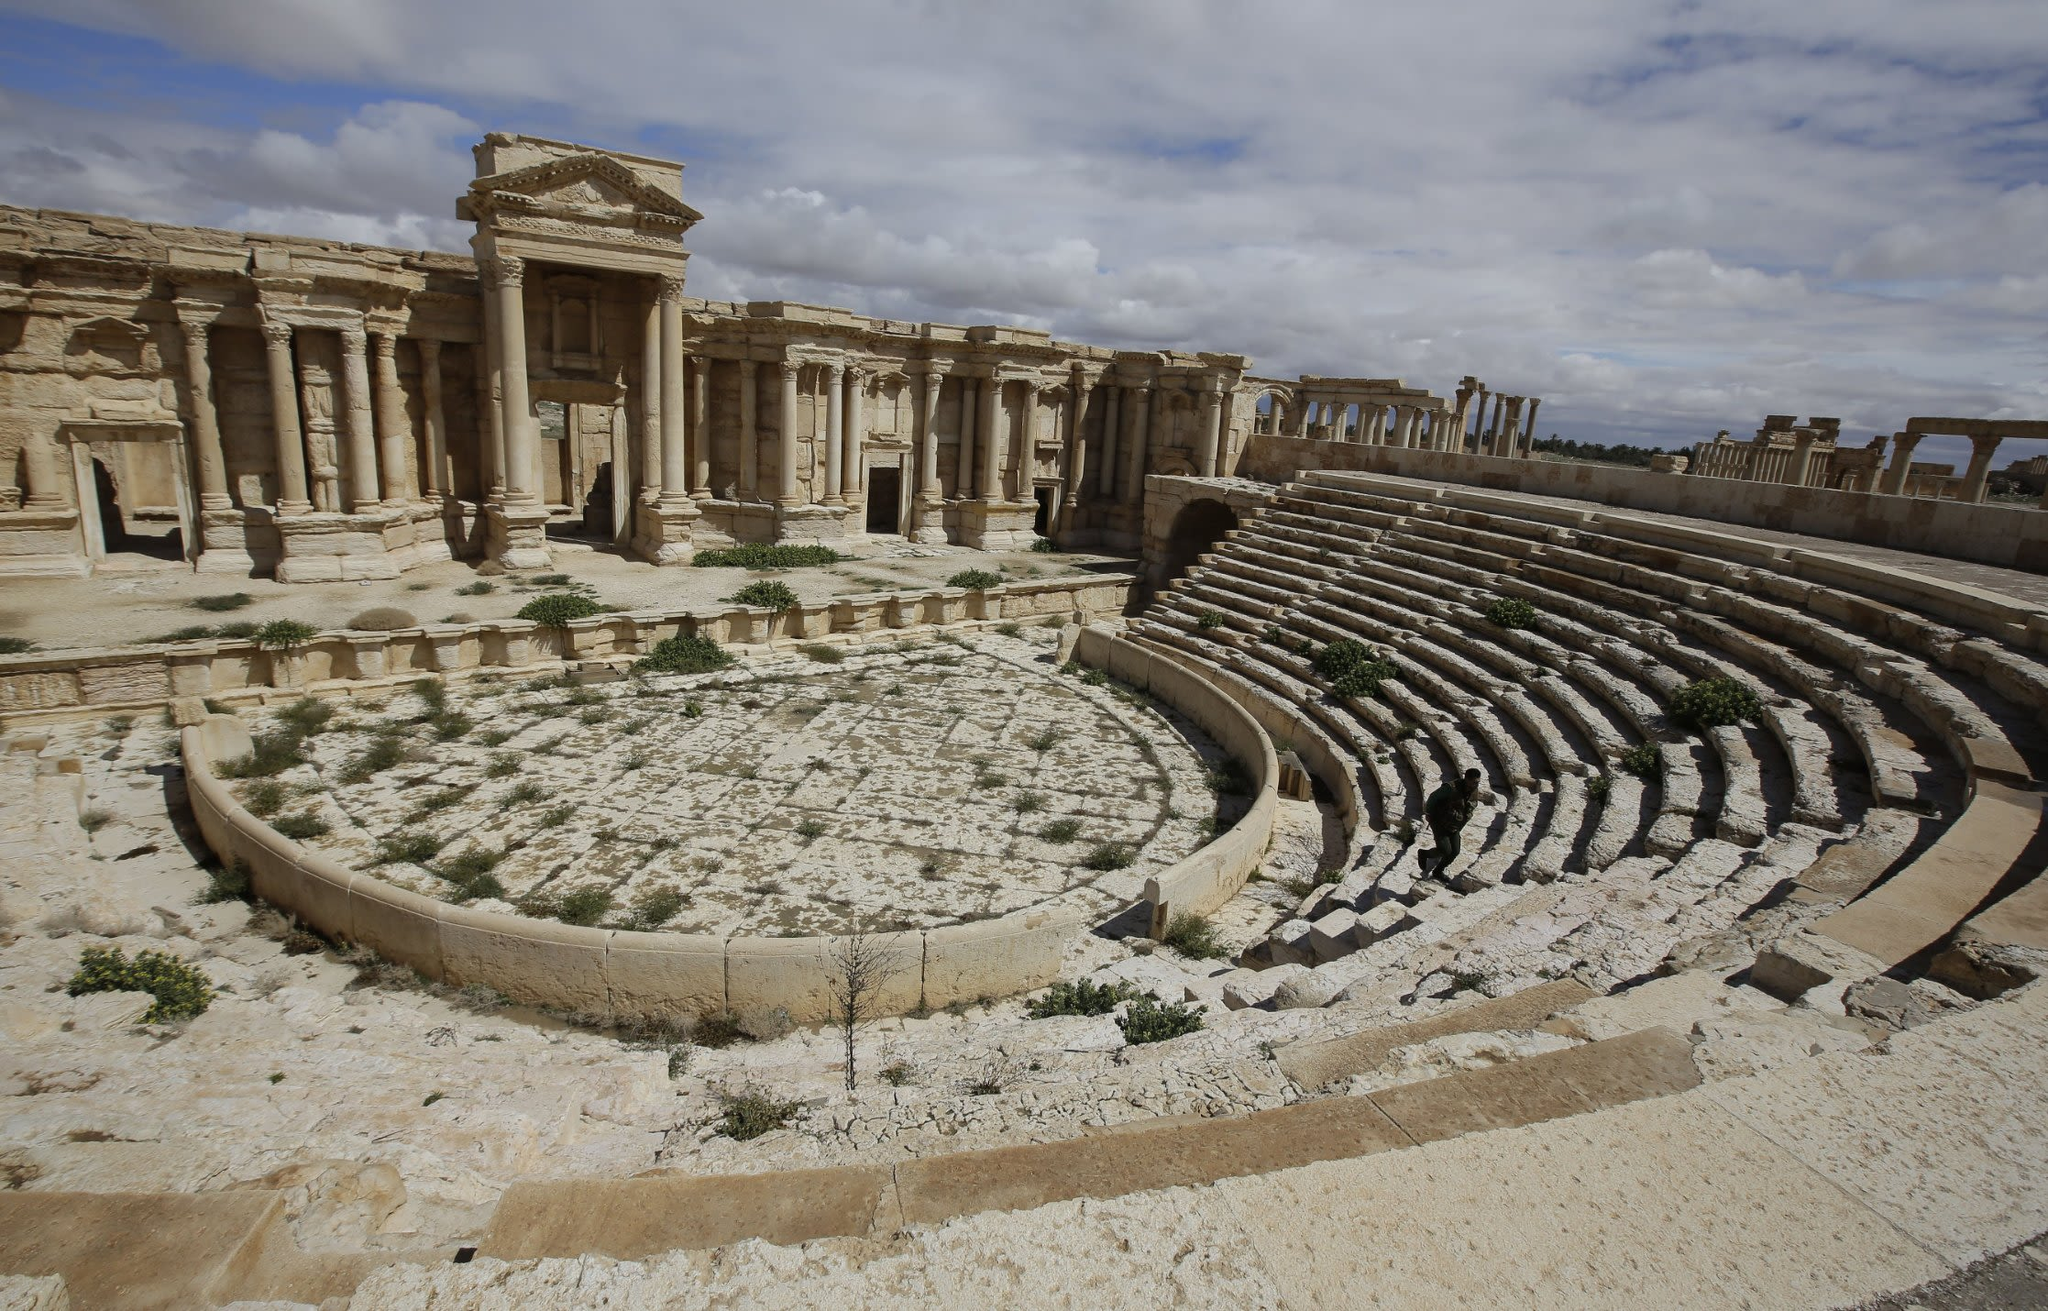What are the key elements in this picture? The image presents a vivid depiction of the ancient theater in Palmyra, Syria. This architectural marvel showcases a semicircular seating arrangement and a central stage, both carved from the local sandstone. The ruins reflect various states of decay, highlighting the impacts of time and historical conflicts. The theater is set against a backdrop of other ruins, which hints at the expansive nature of this archaeological site. The cloudy sky adds a somber tone to the scene, suggesting the historical turbulence experienced by this area. Understanding Palmyra's role as a cultural and economic hub during Roman times can enhance appreciation of its architectural and historical significance. 